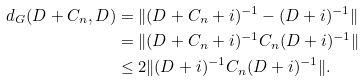<formula> <loc_0><loc_0><loc_500><loc_500>d _ { G } ( D + C _ { n } , D ) & = \| ( D + C _ { n } + i ) ^ { - 1 } - ( D + i ) ^ { - 1 } \| \\ & = \| ( D + C _ { n } + i ) ^ { - 1 } C _ { n } ( D + i ) ^ { - 1 } \| \\ & \leq 2 \| ( D + i ) ^ { - 1 } C _ { n } ( D + i ) ^ { - 1 } \| .</formula> 